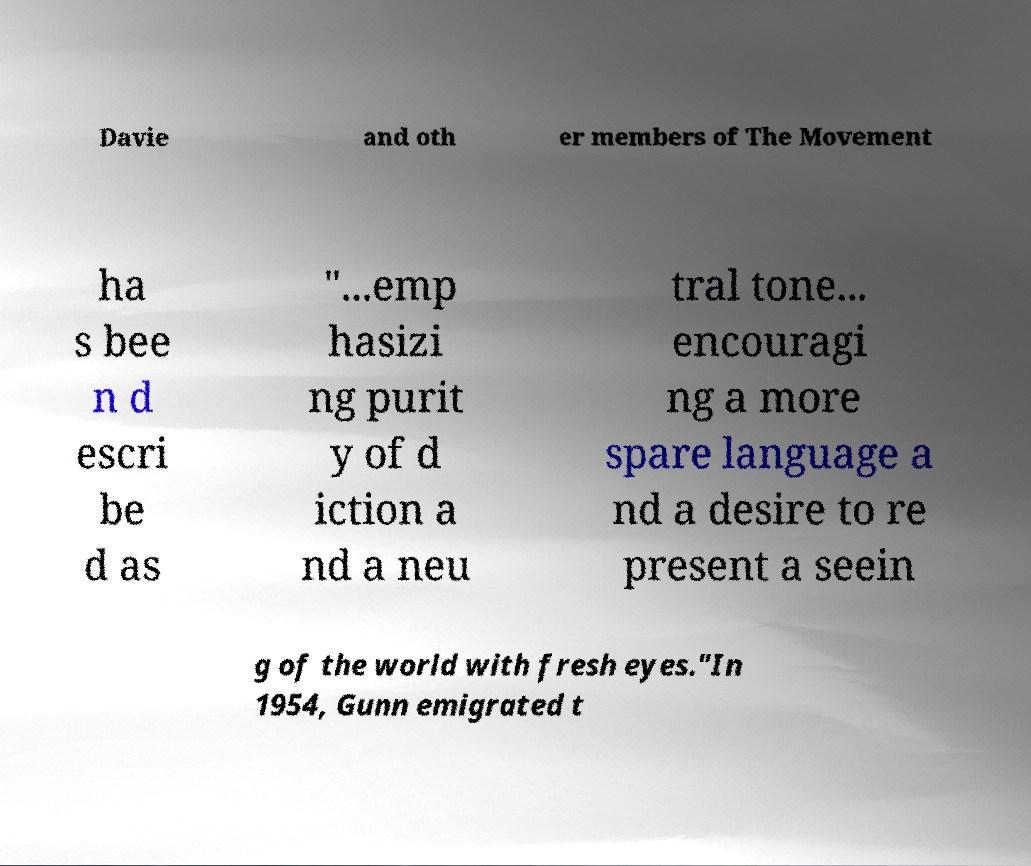Can you accurately transcribe the text from the provided image for me? Davie and oth er members of The Movement ha s bee n d escri be d as "...emp hasizi ng purit y of d iction a nd a neu tral tone... encouragi ng a more spare language a nd a desire to re present a seein g of the world with fresh eyes."In 1954, Gunn emigrated t 